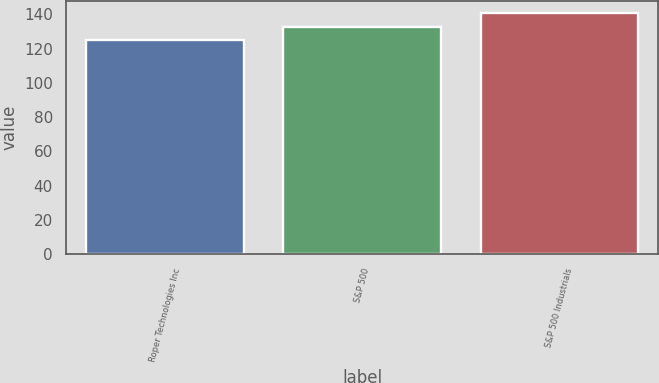Convert chart to OTSL. <chart><loc_0><loc_0><loc_500><loc_500><bar_chart><fcel>Roper Technologies Inc<fcel>S&P 500<fcel>S&P 500 Industrials<nl><fcel>124.89<fcel>132.39<fcel>140.68<nl></chart> 